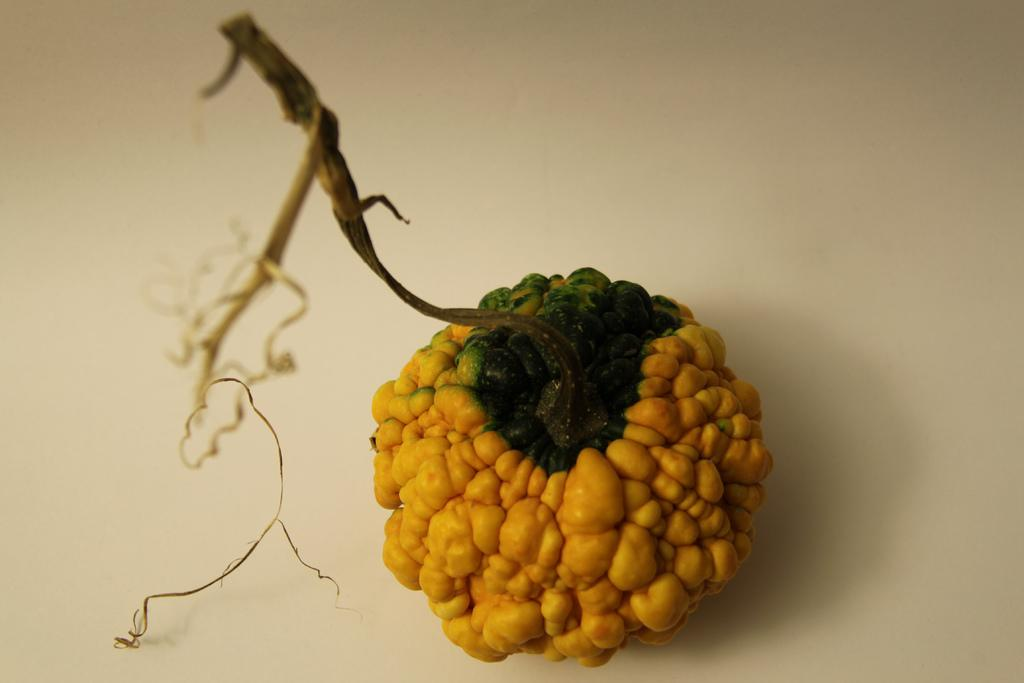What type of object is present in the image? There is a fruit in the image. Can you describe the color of the fruit? The fruit has yellow and green colors. How is the fruit connected to the plant? The fruit is attached to a stem. What color is the background of the image? The background of the image is white in color. What type of farm can be seen in the image? There is no farm present in the image; it features a fruit with a stem and a white background. 